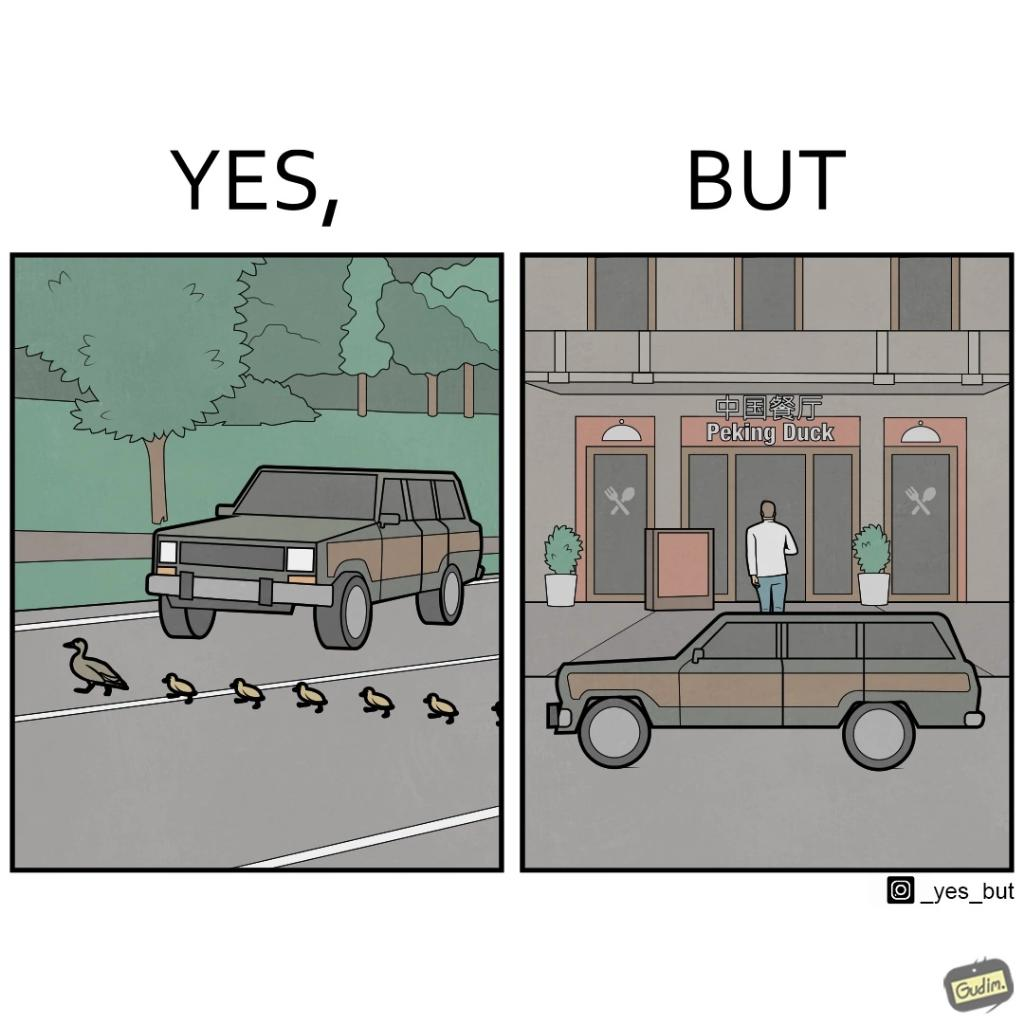Explain the humor or irony in this image. The images are ironic since they show how a man supposedly cares for ducks since he stops his vehicle to give way to queue of ducks allowing them to safely cross a road but on the other hand he goes to a peking duck shop to buy and eat similar ducks after having them killed 